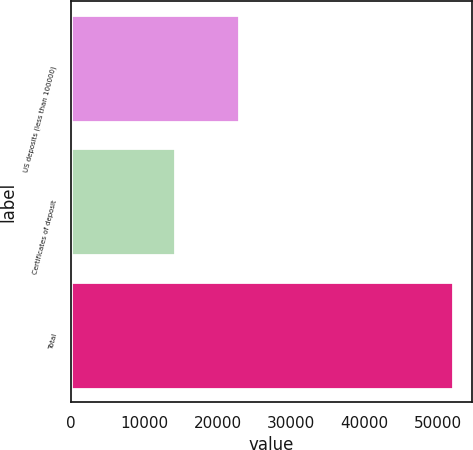<chart> <loc_0><loc_0><loc_500><loc_500><bar_chart><fcel>US deposits (less than 100000)<fcel>Certificates of deposit<fcel>Total<nl><fcel>22899<fcel>14222<fcel>52055<nl></chart> 